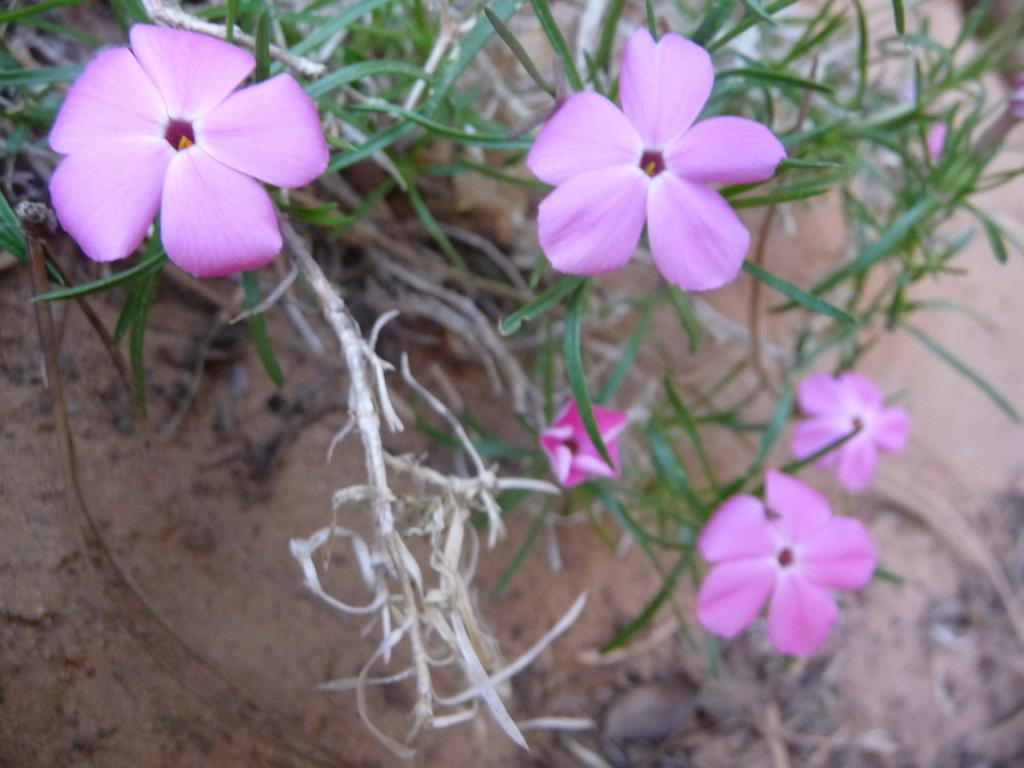What is the main subject of the image? The main subject of the image is a close-up of flowers. What color are the flowers in the image? The flowers are pink in color. Are the flowers part of a larger plant or arrangement? Yes, the flowers are part of a plant. What type of lamp is hanging above the flowers in the image? There is no lamp present in the image; it is a close-up of flowers. Is there a carpenter working on a box near the flowers in the image? There is no carpenter or box present in the image; it is a close-up of flowers. 